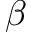<formula> <loc_0><loc_0><loc_500><loc_500>\beta</formula> 